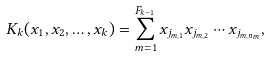Convert formula to latex. <formula><loc_0><loc_0><loc_500><loc_500>K _ { k } ( x _ { 1 } , x _ { 2 } , \dots , x _ { k } ) = \sum _ { m = 1 } ^ { F _ { k - 1 } } x _ { j _ { m , 1 } } x _ { j _ { m , 2 } } \cdots x _ { j _ { m , n _ { m } } } ,</formula> 